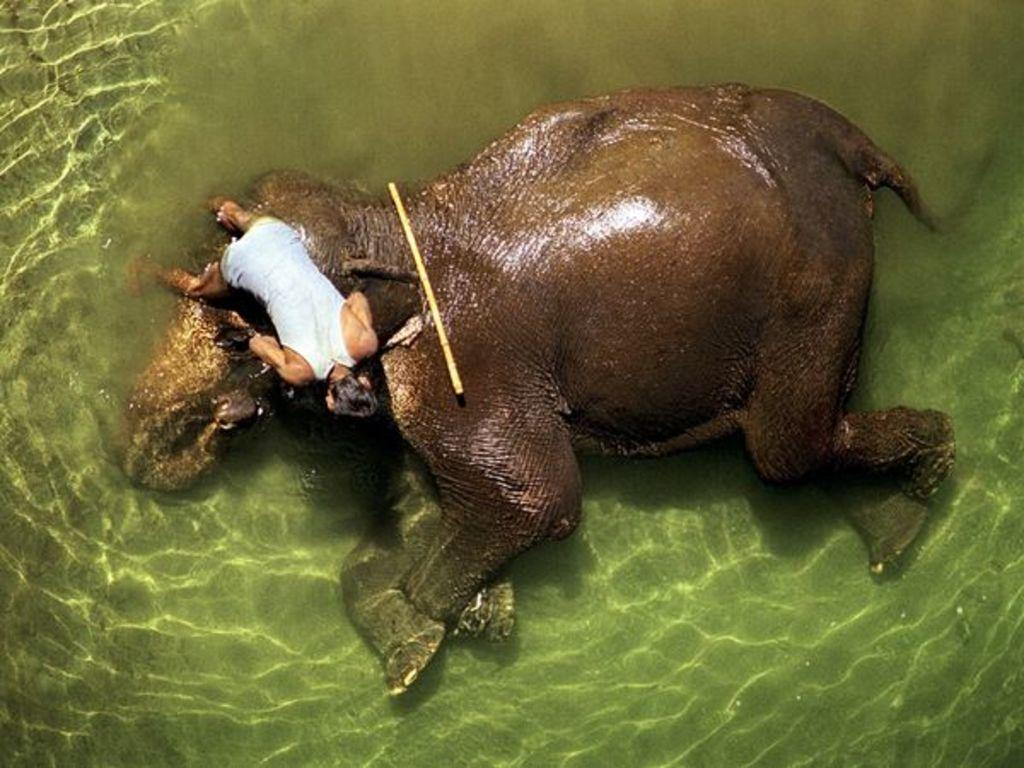What animal is present in the image? There is an elephant in the image. What is the elephant doing in the image? The elephant is lying in the water. Is there anyone else present in the image? Yes, there is a person lying on the elephant. What object can be seen on the elephant? There is a stick on the elephant. What type of farm can be seen in the background of the image? There is no farm visible in the image; it features an elephant lying in the water with a person and a stick on it. 